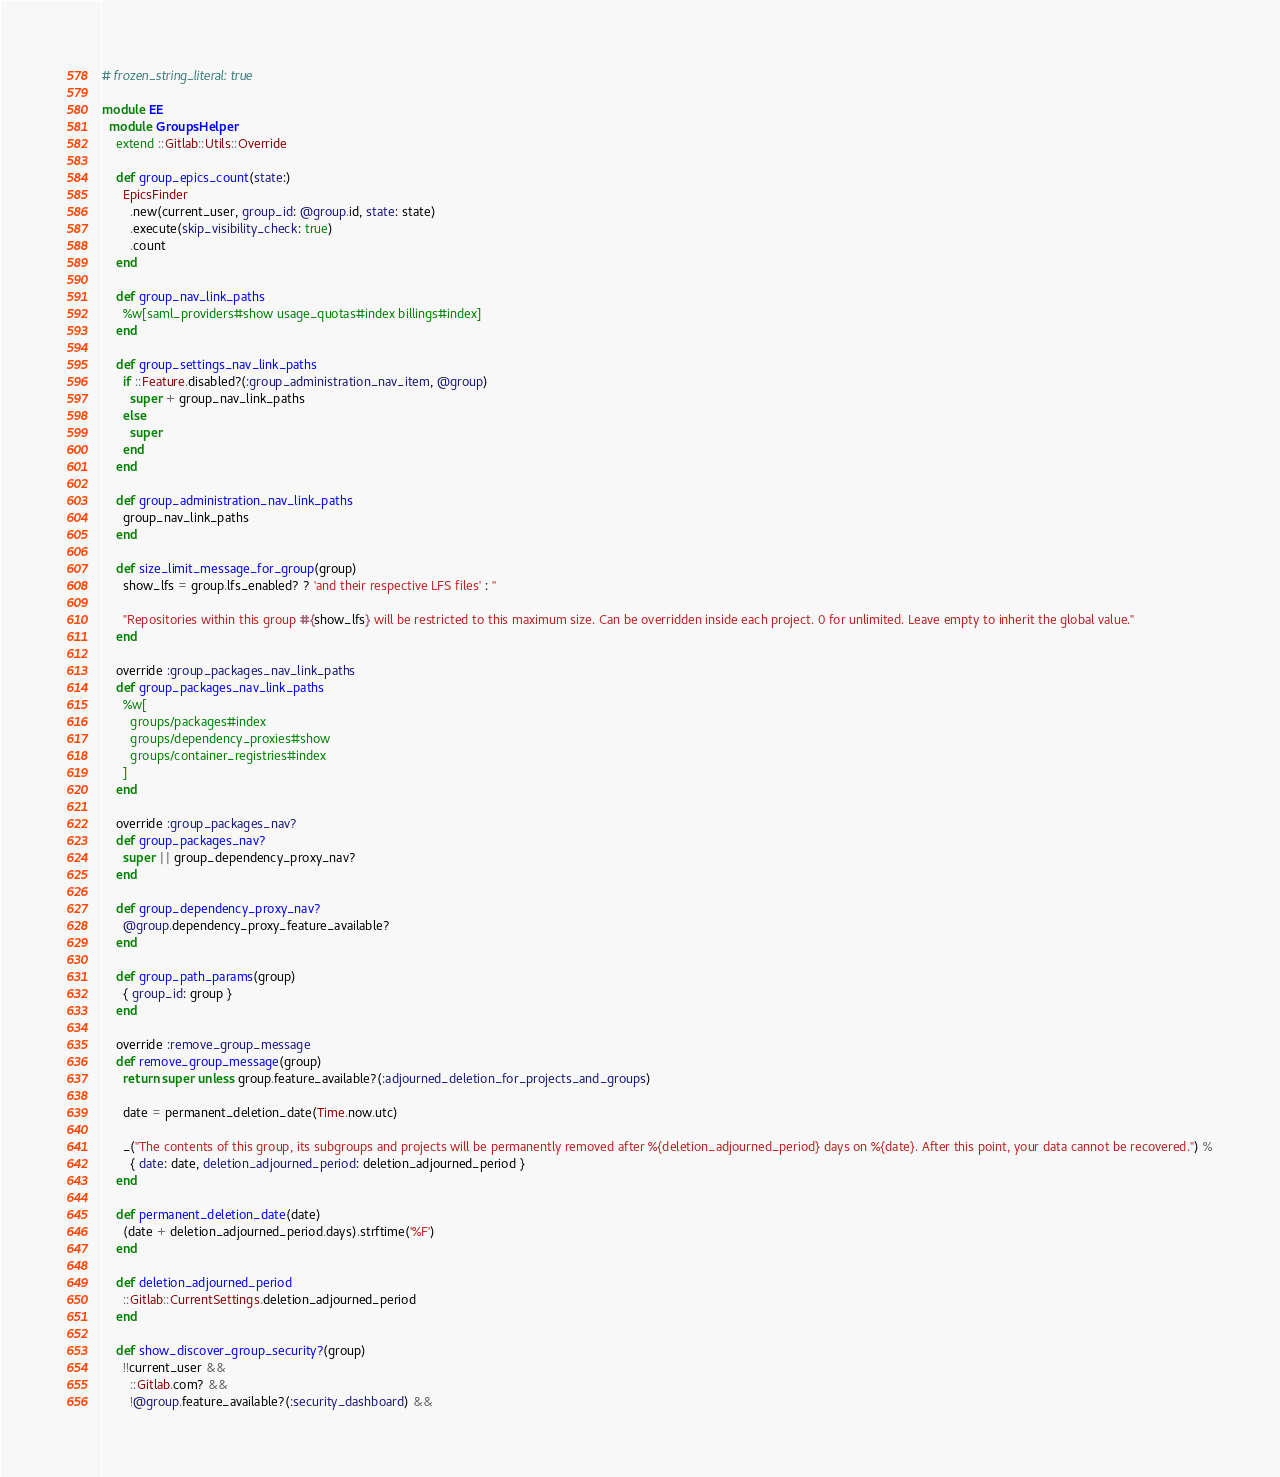<code> <loc_0><loc_0><loc_500><loc_500><_Ruby_># frozen_string_literal: true

module EE
  module GroupsHelper
    extend ::Gitlab::Utils::Override

    def group_epics_count(state:)
      EpicsFinder
        .new(current_user, group_id: @group.id, state: state)
        .execute(skip_visibility_check: true)
        .count
    end

    def group_nav_link_paths
      %w[saml_providers#show usage_quotas#index billings#index]
    end

    def group_settings_nav_link_paths
      if ::Feature.disabled?(:group_administration_nav_item, @group)
        super + group_nav_link_paths
      else
        super
      end
    end

    def group_administration_nav_link_paths
      group_nav_link_paths
    end

    def size_limit_message_for_group(group)
      show_lfs = group.lfs_enabled? ? 'and their respective LFS files' : ''

      "Repositories within this group #{show_lfs} will be restricted to this maximum size. Can be overridden inside each project. 0 for unlimited. Leave empty to inherit the global value."
    end

    override :group_packages_nav_link_paths
    def group_packages_nav_link_paths
      %w[
        groups/packages#index
        groups/dependency_proxies#show
        groups/container_registries#index
      ]
    end

    override :group_packages_nav?
    def group_packages_nav?
      super || group_dependency_proxy_nav?
    end

    def group_dependency_proxy_nav?
      @group.dependency_proxy_feature_available?
    end

    def group_path_params(group)
      { group_id: group }
    end

    override :remove_group_message
    def remove_group_message(group)
      return super unless group.feature_available?(:adjourned_deletion_for_projects_and_groups)

      date = permanent_deletion_date(Time.now.utc)

      _("The contents of this group, its subgroups and projects will be permanently removed after %{deletion_adjourned_period} days on %{date}. After this point, your data cannot be recovered.") %
        { date: date, deletion_adjourned_period: deletion_adjourned_period }
    end

    def permanent_deletion_date(date)
      (date + deletion_adjourned_period.days).strftime('%F')
    end

    def deletion_adjourned_period
      ::Gitlab::CurrentSettings.deletion_adjourned_period
    end

    def show_discover_group_security?(group)
      !!current_user &&
        ::Gitlab.com? &&
        !@group.feature_available?(:security_dashboard) &&</code> 